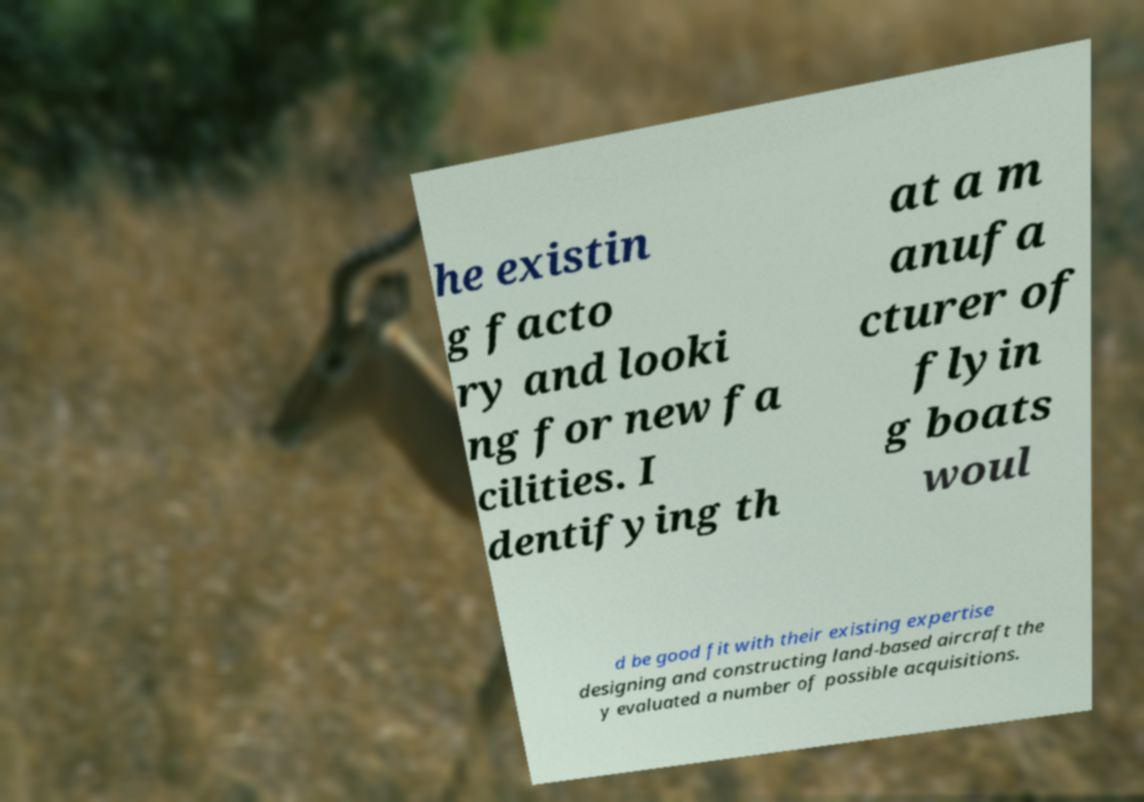What messages or text are displayed in this image? I need them in a readable, typed format. he existin g facto ry and looki ng for new fa cilities. I dentifying th at a m anufa cturer of flyin g boats woul d be good fit with their existing expertise designing and constructing land-based aircraft the y evaluated a number of possible acquisitions. 